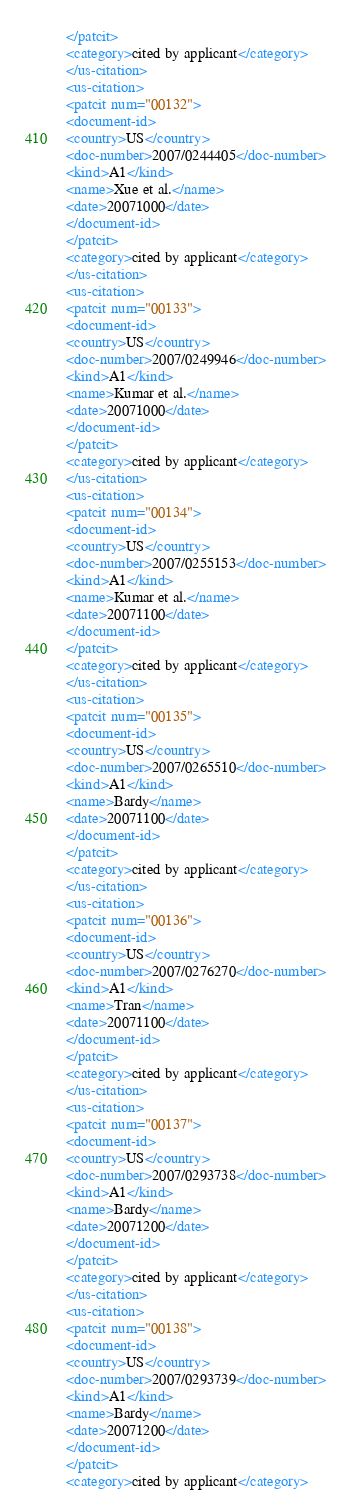Convert code to text. <code><loc_0><loc_0><loc_500><loc_500><_XML_></patcit>
<category>cited by applicant</category>
</us-citation>
<us-citation>
<patcit num="00132">
<document-id>
<country>US</country>
<doc-number>2007/0244405</doc-number>
<kind>A1</kind>
<name>Xue et al.</name>
<date>20071000</date>
</document-id>
</patcit>
<category>cited by applicant</category>
</us-citation>
<us-citation>
<patcit num="00133">
<document-id>
<country>US</country>
<doc-number>2007/0249946</doc-number>
<kind>A1</kind>
<name>Kumar et al.</name>
<date>20071000</date>
</document-id>
</patcit>
<category>cited by applicant</category>
</us-citation>
<us-citation>
<patcit num="00134">
<document-id>
<country>US</country>
<doc-number>2007/0255153</doc-number>
<kind>A1</kind>
<name>Kumar et al.</name>
<date>20071100</date>
</document-id>
</patcit>
<category>cited by applicant</category>
</us-citation>
<us-citation>
<patcit num="00135">
<document-id>
<country>US</country>
<doc-number>2007/0265510</doc-number>
<kind>A1</kind>
<name>Bardy</name>
<date>20071100</date>
</document-id>
</patcit>
<category>cited by applicant</category>
</us-citation>
<us-citation>
<patcit num="00136">
<document-id>
<country>US</country>
<doc-number>2007/0276270</doc-number>
<kind>A1</kind>
<name>Tran</name>
<date>20071100</date>
</document-id>
</patcit>
<category>cited by applicant</category>
</us-citation>
<us-citation>
<patcit num="00137">
<document-id>
<country>US</country>
<doc-number>2007/0293738</doc-number>
<kind>A1</kind>
<name>Bardy</name>
<date>20071200</date>
</document-id>
</patcit>
<category>cited by applicant</category>
</us-citation>
<us-citation>
<patcit num="00138">
<document-id>
<country>US</country>
<doc-number>2007/0293739</doc-number>
<kind>A1</kind>
<name>Bardy</name>
<date>20071200</date>
</document-id>
</patcit>
<category>cited by applicant</category></code> 